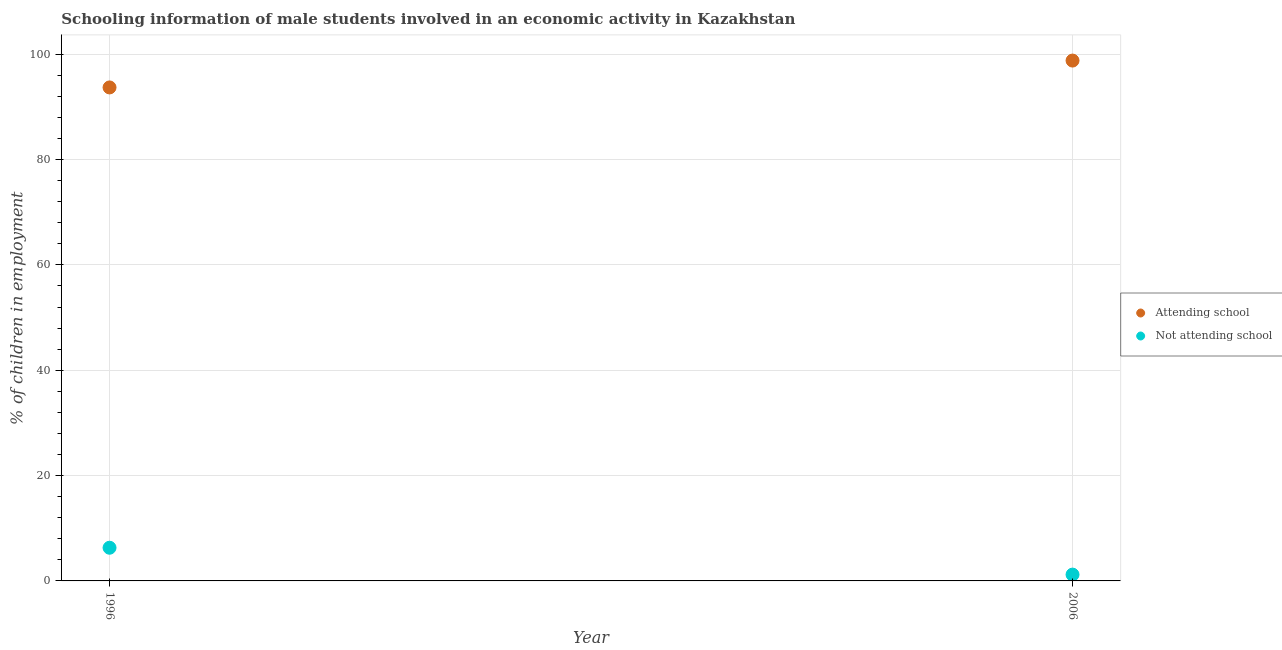How many different coloured dotlines are there?
Provide a succinct answer. 2. What is the percentage of employed males who are attending school in 2006?
Make the answer very short. 98.8. Across all years, what is the maximum percentage of employed males who are attending school?
Make the answer very short. 98.8. In which year was the percentage of employed males who are not attending school maximum?
Provide a succinct answer. 1996. In which year was the percentage of employed males who are attending school minimum?
Offer a very short reply. 1996. What is the total percentage of employed males who are attending school in the graph?
Make the answer very short. 192.5. What is the difference between the percentage of employed males who are attending school in 1996 and that in 2006?
Ensure brevity in your answer.  -5.1. What is the difference between the percentage of employed males who are not attending school in 2006 and the percentage of employed males who are attending school in 1996?
Give a very brief answer. -92.5. What is the average percentage of employed males who are not attending school per year?
Your answer should be very brief. 3.75. In the year 1996, what is the difference between the percentage of employed males who are not attending school and percentage of employed males who are attending school?
Your answer should be compact. -87.4. In how many years, is the percentage of employed males who are not attending school greater than 60 %?
Offer a very short reply. 0. What is the ratio of the percentage of employed males who are attending school in 1996 to that in 2006?
Keep it short and to the point. 0.95. Is the percentage of employed males who are attending school strictly greater than the percentage of employed males who are not attending school over the years?
Provide a short and direct response. Yes. Is the percentage of employed males who are not attending school strictly less than the percentage of employed males who are attending school over the years?
Offer a terse response. Yes. Where does the legend appear in the graph?
Give a very brief answer. Center right. How many legend labels are there?
Your answer should be very brief. 2. How are the legend labels stacked?
Your answer should be very brief. Vertical. What is the title of the graph?
Give a very brief answer. Schooling information of male students involved in an economic activity in Kazakhstan. What is the label or title of the Y-axis?
Give a very brief answer. % of children in employment. What is the % of children in employment of Attending school in 1996?
Your answer should be compact. 93.7. What is the % of children in employment in Not attending school in 1996?
Keep it short and to the point. 6.3. What is the % of children in employment in Attending school in 2006?
Your answer should be very brief. 98.8. Across all years, what is the maximum % of children in employment in Attending school?
Offer a terse response. 98.8. Across all years, what is the maximum % of children in employment in Not attending school?
Your answer should be very brief. 6.3. Across all years, what is the minimum % of children in employment of Attending school?
Offer a very short reply. 93.7. What is the total % of children in employment of Attending school in the graph?
Ensure brevity in your answer.  192.5. What is the total % of children in employment of Not attending school in the graph?
Make the answer very short. 7.5. What is the difference between the % of children in employment of Attending school in 1996 and that in 2006?
Your answer should be very brief. -5.1. What is the difference between the % of children in employment of Attending school in 1996 and the % of children in employment of Not attending school in 2006?
Keep it short and to the point. 92.5. What is the average % of children in employment of Attending school per year?
Offer a very short reply. 96.25. What is the average % of children in employment of Not attending school per year?
Your answer should be very brief. 3.75. In the year 1996, what is the difference between the % of children in employment of Attending school and % of children in employment of Not attending school?
Offer a very short reply. 87.4. In the year 2006, what is the difference between the % of children in employment of Attending school and % of children in employment of Not attending school?
Your answer should be compact. 97.6. What is the ratio of the % of children in employment of Attending school in 1996 to that in 2006?
Provide a short and direct response. 0.95. What is the ratio of the % of children in employment in Not attending school in 1996 to that in 2006?
Provide a short and direct response. 5.25. What is the difference between the highest and the second highest % of children in employment of Attending school?
Your response must be concise. 5.1. What is the difference between the highest and the second highest % of children in employment in Not attending school?
Provide a succinct answer. 5.1. 